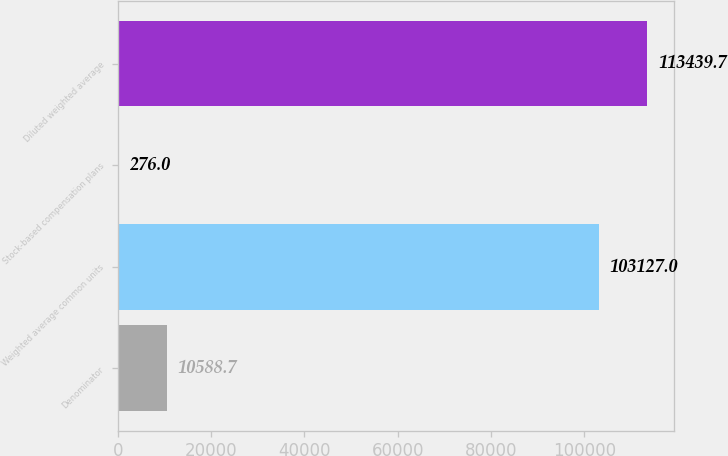Convert chart to OTSL. <chart><loc_0><loc_0><loc_500><loc_500><bar_chart><fcel>Denominator<fcel>Weighted average common units<fcel>Stock-based compensation plans<fcel>Diluted weighted average<nl><fcel>10588.7<fcel>103127<fcel>276<fcel>113440<nl></chart> 